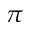Convert formula to latex. <formula><loc_0><loc_0><loc_500><loc_500>\pi</formula> 